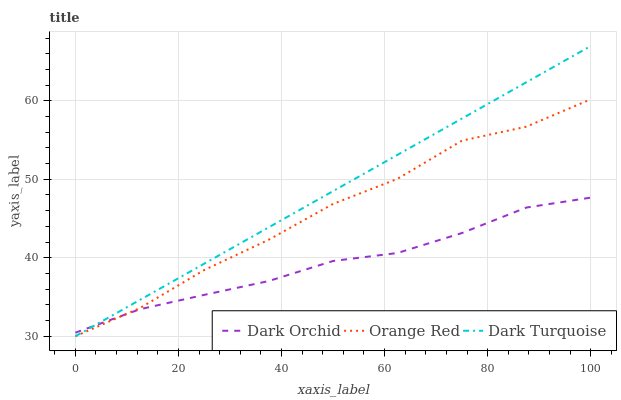Does Dark Orchid have the minimum area under the curve?
Answer yes or no. Yes. Does Dark Turquoise have the maximum area under the curve?
Answer yes or no. Yes. Does Orange Red have the minimum area under the curve?
Answer yes or no. No. Does Orange Red have the maximum area under the curve?
Answer yes or no. No. Is Dark Turquoise the smoothest?
Answer yes or no. Yes. Is Orange Red the roughest?
Answer yes or no. Yes. Is Dark Orchid the smoothest?
Answer yes or no. No. Is Dark Orchid the roughest?
Answer yes or no. No. Does Dark Turquoise have the lowest value?
Answer yes or no. Yes. Does Dark Orchid have the lowest value?
Answer yes or no. No. Does Dark Turquoise have the highest value?
Answer yes or no. Yes. Does Orange Red have the highest value?
Answer yes or no. No. Does Dark Orchid intersect Orange Red?
Answer yes or no. Yes. Is Dark Orchid less than Orange Red?
Answer yes or no. No. Is Dark Orchid greater than Orange Red?
Answer yes or no. No. 